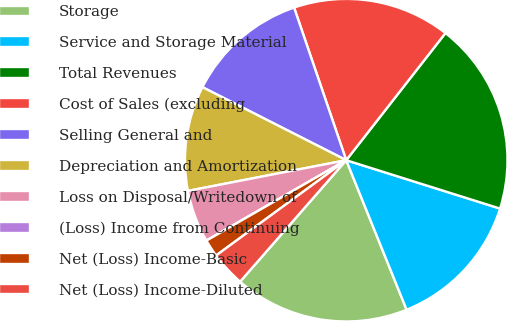<chart> <loc_0><loc_0><loc_500><loc_500><pie_chart><fcel>Storage<fcel>Service and Storage Material<fcel>Total Revenues<fcel>Cost of Sales (excluding<fcel>Selling General and<fcel>Depreciation and Amortization<fcel>Loss on Disposal/Writedown of<fcel>(Loss) Income from Continuing<fcel>Net (Loss) Income-Basic<fcel>Net (Loss) Income-Diluted<nl><fcel>17.54%<fcel>14.04%<fcel>19.3%<fcel>15.79%<fcel>12.28%<fcel>10.53%<fcel>5.26%<fcel>0.0%<fcel>1.75%<fcel>3.51%<nl></chart> 